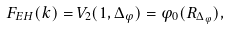<formula> <loc_0><loc_0><loc_500><loc_500>F _ { E H } ( k ) = V _ { 2 } ( 1 , \Delta _ { \varphi } ) = \varphi _ { 0 } ( R _ { \Delta _ { \varphi } } ) ,</formula> 